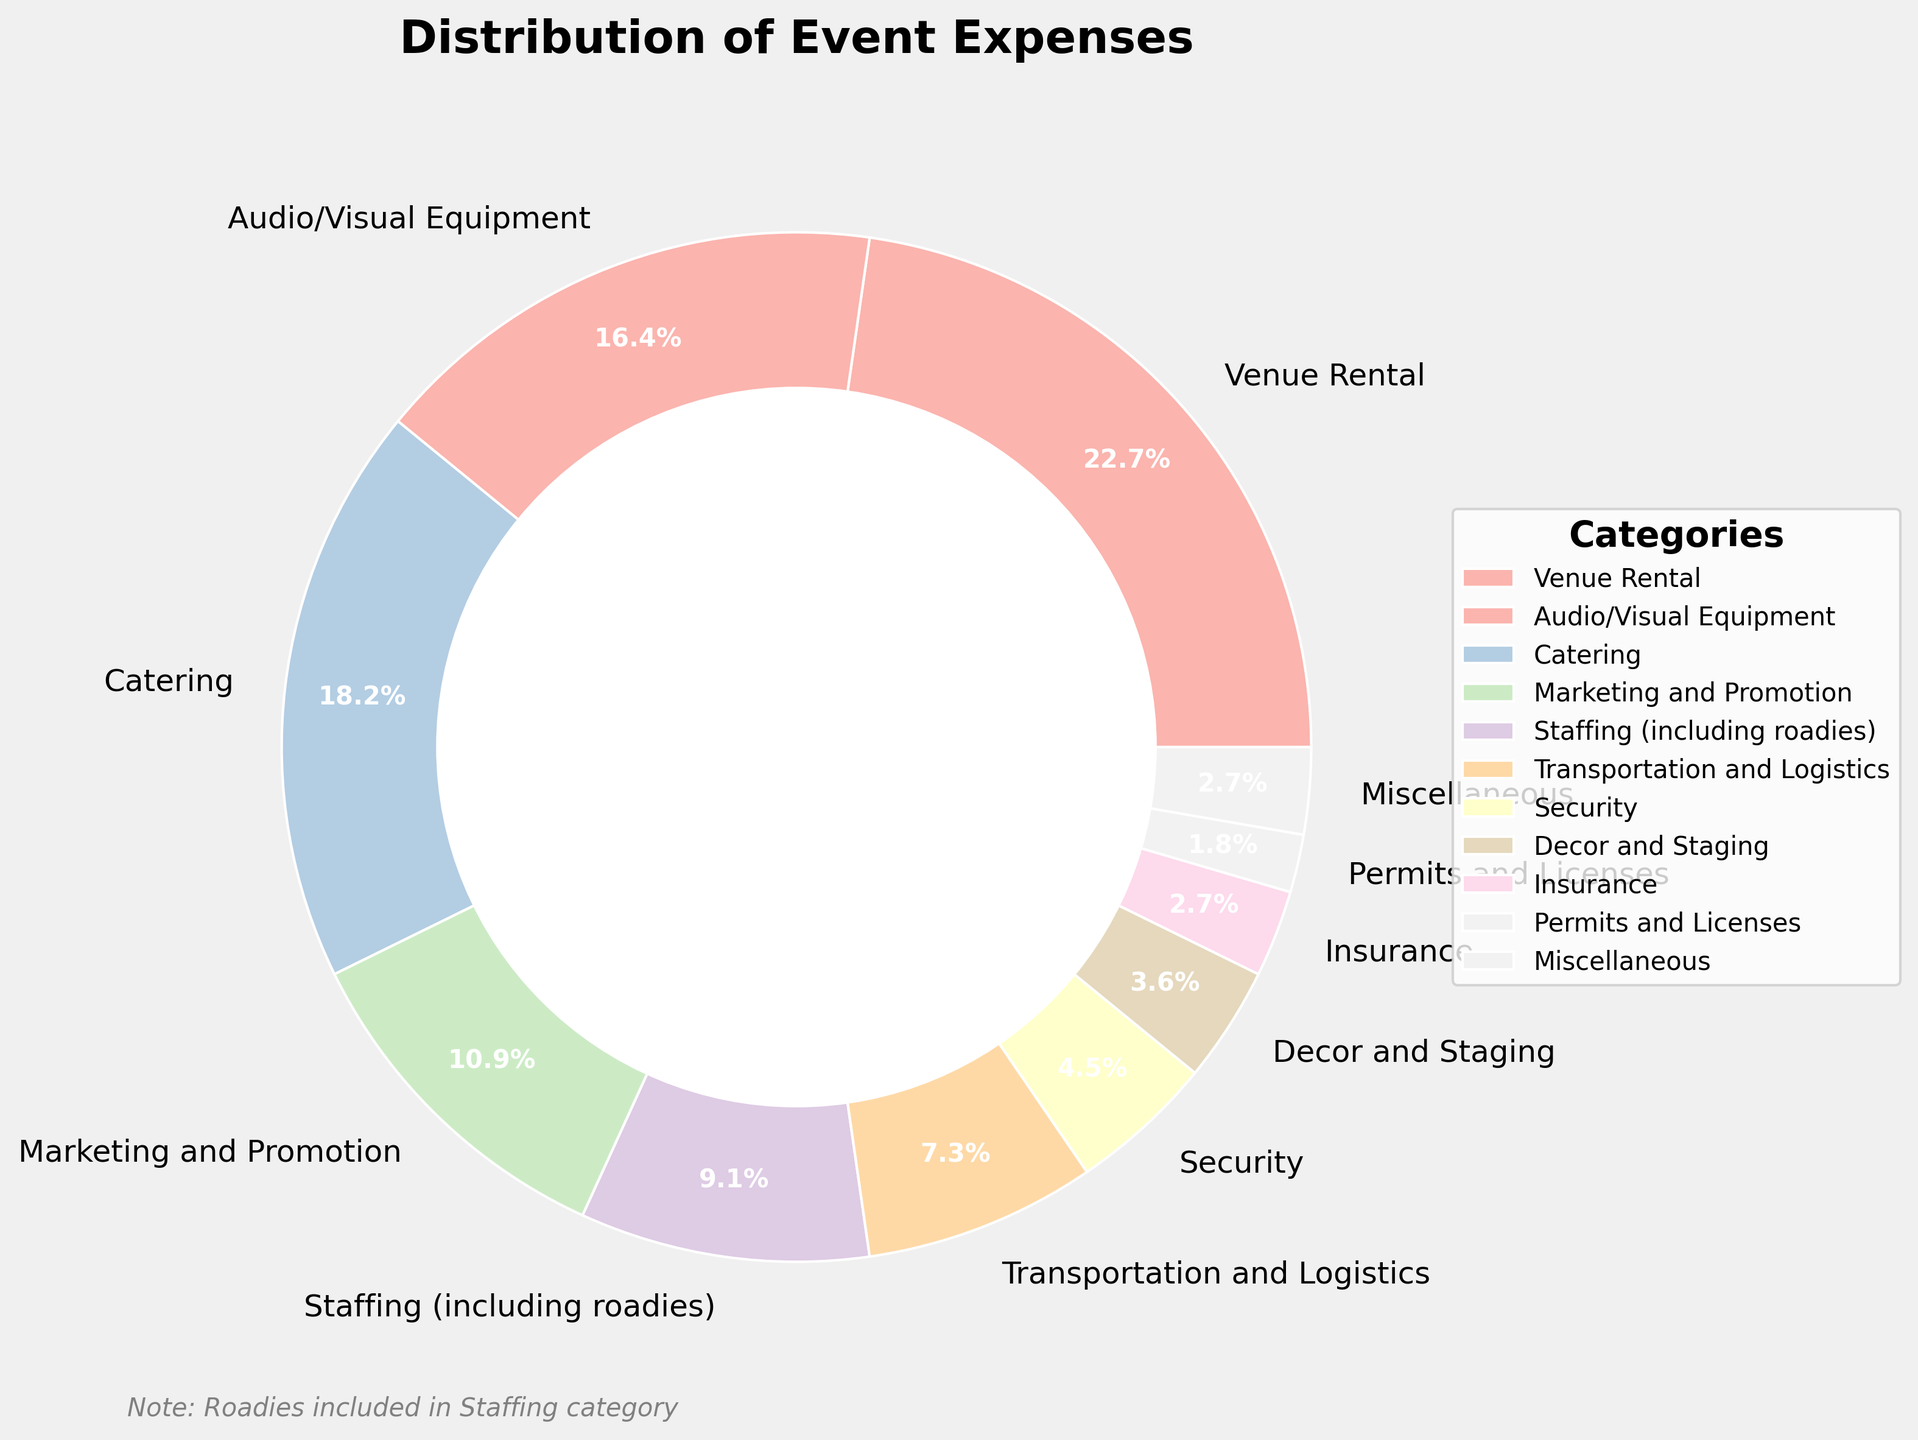What’s the largest expense category? The figure shows individual expense categories with their proportions clearly marked. We need to identify the segment with the highest percentage value. The largest slice of the pie is labeled “Venue Rental” which accounts for 25% of the total expenses.
Answer: Venue Rental What’s the total percentage of Catering and Marketing and Promotion expenses combined? First, observe the Catering segment which is 20% and the Marketing and Promotion segment which is 12%. Adding these two percentages together gives 20% + 12% = 32%.
Answer: 32% Which expense category is the smallest? We need to identify the segment with the smallest percentage value. The pie chart indicates that “Permits and Licenses” has the smallest slice, labeled with 2%.
Answer: Permits and Licenses What is the percentage difference between Audio/Visual Equipment and Staffing? The Audio/Visual Equipment expense is 18% and Staffing expense is 10%. Subtracting the latter from the former gives 18% - 10% = 8%.
Answer: 8% Are there more expenses allocated to Catering or Transportation and Logistics? Compare the percentages of Catering (20%) and Transportation and Logistics (8%). Catering has a higher percentage.
Answer: Catering Which expense categories have exactly 3% allocation? The figure shows that both “Insurance” and “Miscellaneous” categories have slices labeled with 3%.
Answer: Insurance and Miscellaneous What is the combined percentage of expenses for Staffing, Security, and Decor and Staging? Identify each category’s percentage: Staffing (10%), Security (5%), Decor and Staging (4%). Adding these together: 10% + 5% + 4% = 19%.
Answer: 19% Which categories together account for over 40% of the total expenses? We need to find categories whose combined percentages exceed 40%. Adding “Venue Rental” (25%) and “Catering” (20%) gives a total of 45%, which is over 40%.
Answer: Venue Rental and Catering 